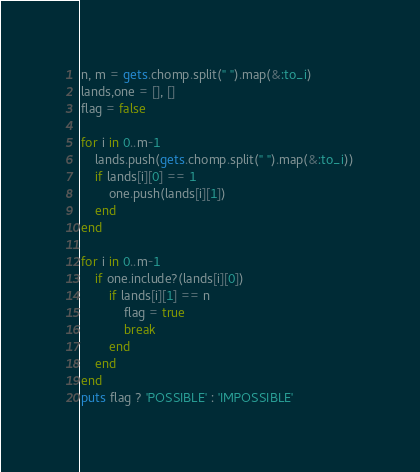Convert code to text. <code><loc_0><loc_0><loc_500><loc_500><_Ruby_>n, m = gets.chomp.split(" ").map(&:to_i)
lands,one = [], []
flag = false

for i in 0..m-1
	lands.push(gets.chomp.split(" ").map(&:to_i))
	if lands[i][0] == 1
		one.push(lands[i][1])
	end
end

for i in 0..m-1
	if one.include?(lands[i][0])
		if lands[i][1] == n
			flag = true
			break
		end
	end
end
puts flag ? 'POSSIBLE' : 'IMPOSSIBLE'

</code> 